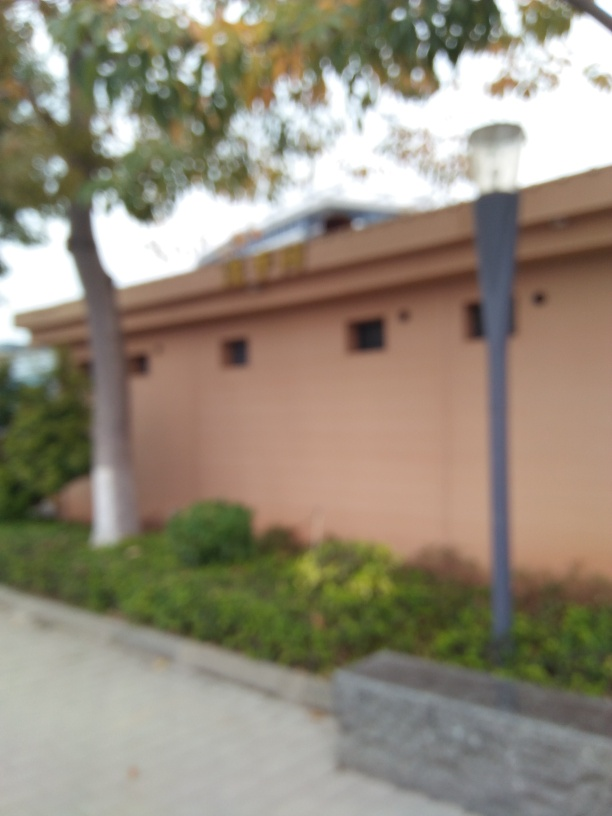Can you describe what might be behind the haziness? While the specific details cannot be discerned due to the blur, the context suggests it could be a residential or commercial building with potentially one or two stories, judging by what appears to be a roofline. The haziness could be a result of a camera focus issue or an intentional artistic choice. What could be the reason for capturing an image like this? If intentional, such a photograph could be an attempt to evoke a sense of impermanence or the fleeting nature of memory. If unintentional, it may simply be the result of a camera mishap. In an artistic context, this style might be used to draw attention to form and color over detail. 